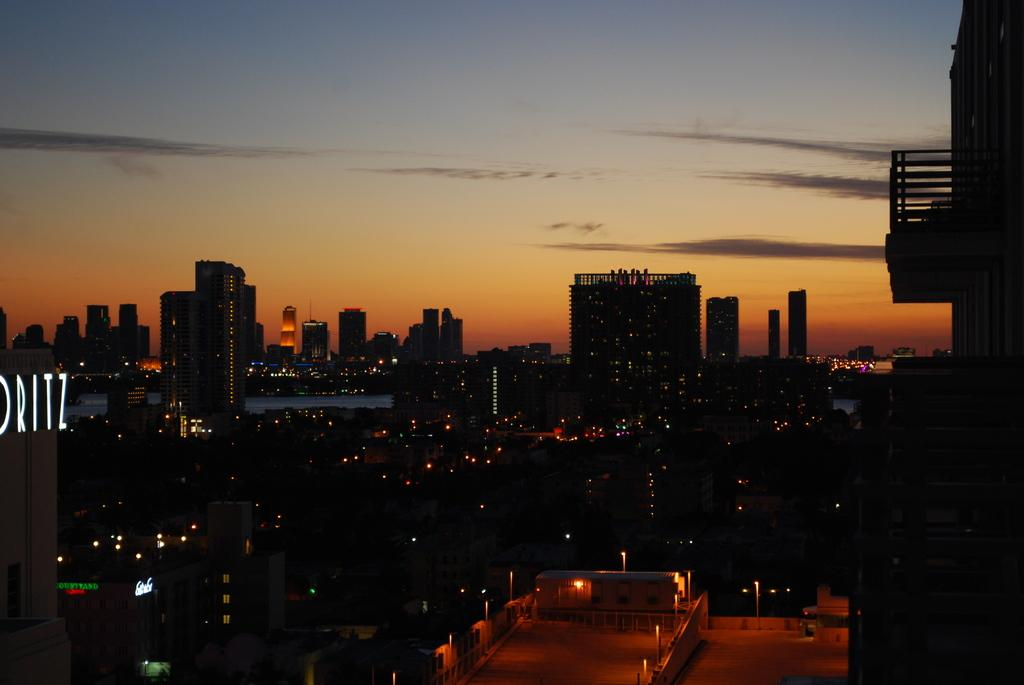What type of structures are visible in the image? There are buildings with lights in the image. What can be seen at the top of the image? The sky is visible at the top of the image. What flavor of seed is being sold at the store in the image? There is no store or seed present in the image; it only features buildings with lights and the sky. 